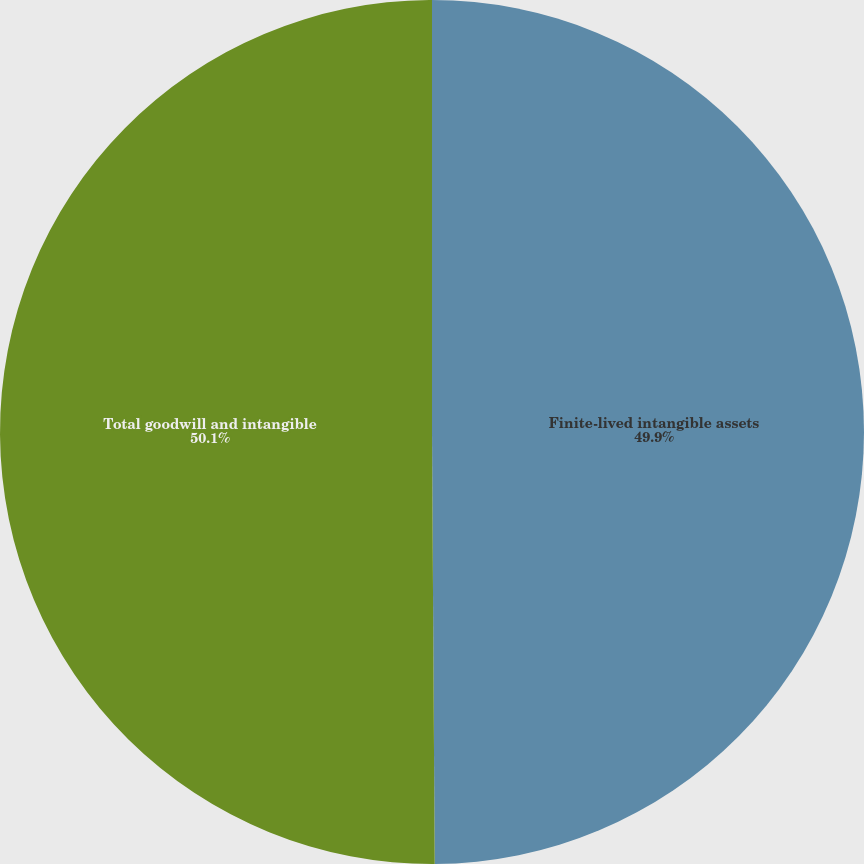<chart> <loc_0><loc_0><loc_500><loc_500><pie_chart><fcel>Finite-lived intangible assets<fcel>Total goodwill and intangible<nl><fcel>49.9%<fcel>50.1%<nl></chart> 